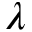<formula> <loc_0><loc_0><loc_500><loc_500>\lambda</formula> 